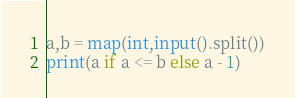<code> <loc_0><loc_0><loc_500><loc_500><_Python_>a,b = map(int,input().split())
print(a if a <= b else a - 1)</code> 